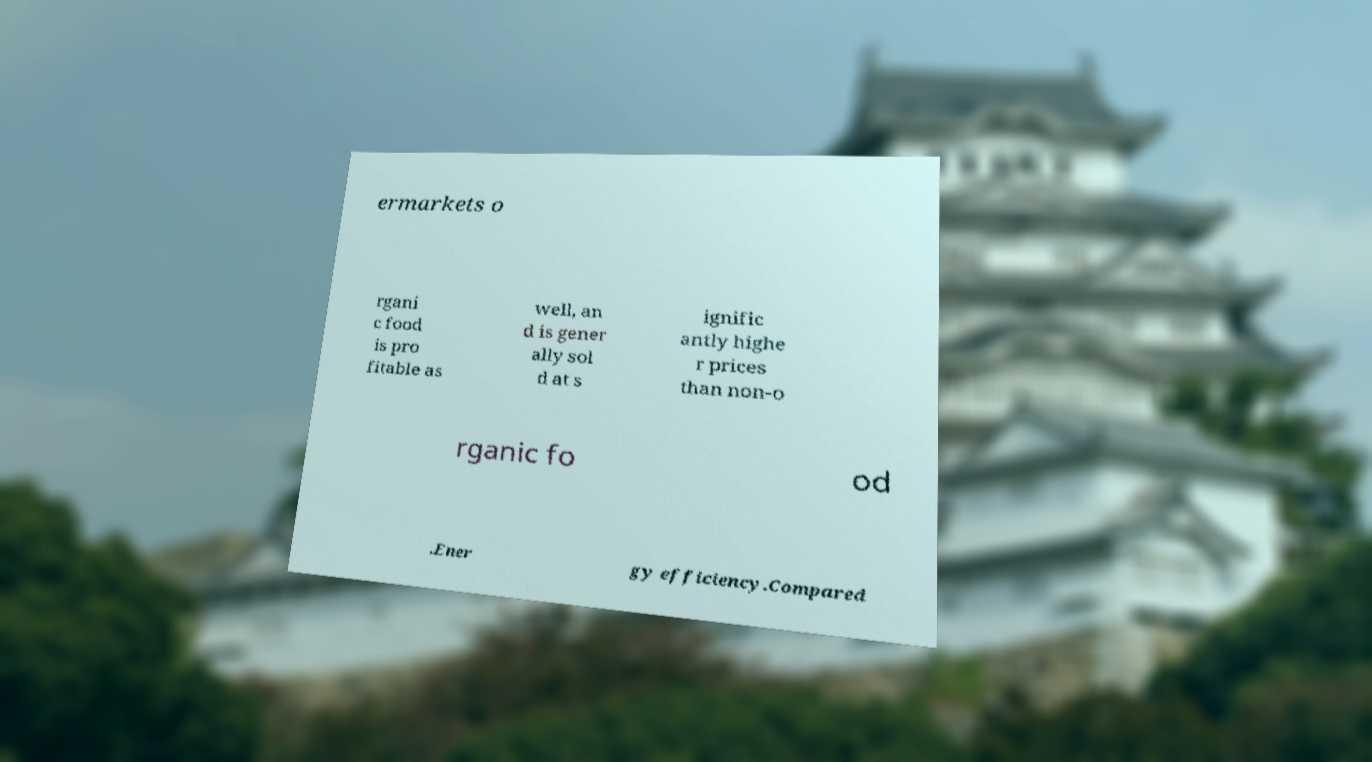Please read and relay the text visible in this image. What does it say? ermarkets o rgani c food is pro fitable as well, an d is gener ally sol d at s ignific antly highe r prices than non-o rganic fo od .Ener gy efficiency.Compared 